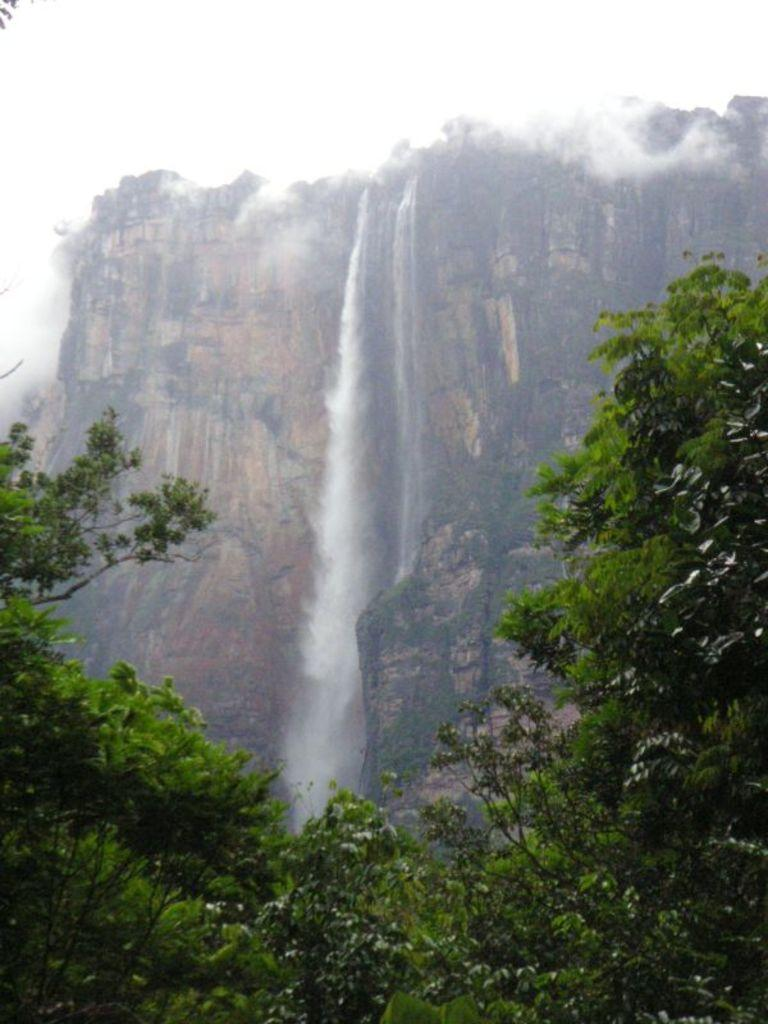What natural feature is the main subject of the image? There is a waterfall in the image. Where does the waterfall originate from? The waterfall is coming from a mountain. What type of vegetation can be seen at the bottom of the image? There are many trees at the bottom of the image. What is visible at the top of the image? The sky is visible at the top of the image. What can be observed in the sky? Clouds are present in the sky. What is the maid doing at the waterfall in the image? There is no maid present in the image. What is the reason for the waterfall's existence in the image? The reason for the waterfall's existence is due to the natural flow of water from the mountain, not any specific reason. How does the waterfall show respect to the trees at the bottom of the image? The waterfall does not show respect to the trees; it is a natural occurrence and not capable of expressing emotions or respect. 